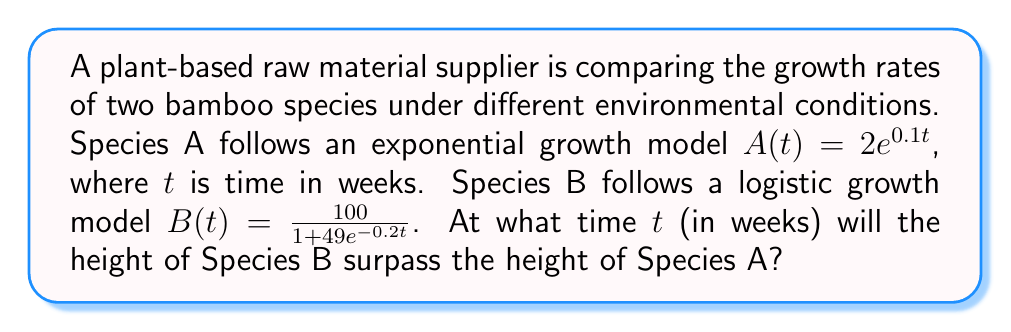Provide a solution to this math problem. To find the time when Species B surpasses Species A, we need to solve the equation:

$$A(t) = B(t)$$

Substituting the given functions:

$$2e^{0.1t} = \frac{100}{1 + 49e^{-0.2t}}$$

Multiply both sides by $(1 + 49e^{-0.2t})$:

$$2e^{0.1t}(1 + 49e^{-0.2t}) = 100$$

Expand the left side:

$$2e^{0.1t} + 98e^{-0.1t} = 100$$

Divide both sides by 2:

$$e^{0.1t} + 49e^{-0.1t} = 50$$

Let $u = e^{0.1t}$. Then $e^{-0.1t} = \frac{1}{u}$. Substitute:

$$u + \frac{49}{u} = 50$$

Multiply both sides by $u$:

$$u^2 + 49 = 50u$$

Rearrange to standard quadratic form:

$$u^2 - 50u + 49 = 0$$

Use the quadratic formula to solve for $u$:

$$u = \frac{50 \pm \sqrt{2500 - 196}}{2} = \frac{50 \pm \sqrt{2304}}{2} = \frac{50 \pm 48}{2}$$

The positive solution is:

$$u = \frac{50 + 48}{2} = 49$$

Since $u = e^{0.1t}$, we can solve for $t$:

$$e^{0.1t} = 49$$
$$0.1t = \ln(49)$$
$$t = \frac{\ln(49)}{0.1} \approx 39.06$$

Therefore, Species B will surpass Species A after approximately 39.06 weeks.
Answer: 39.06 weeks 